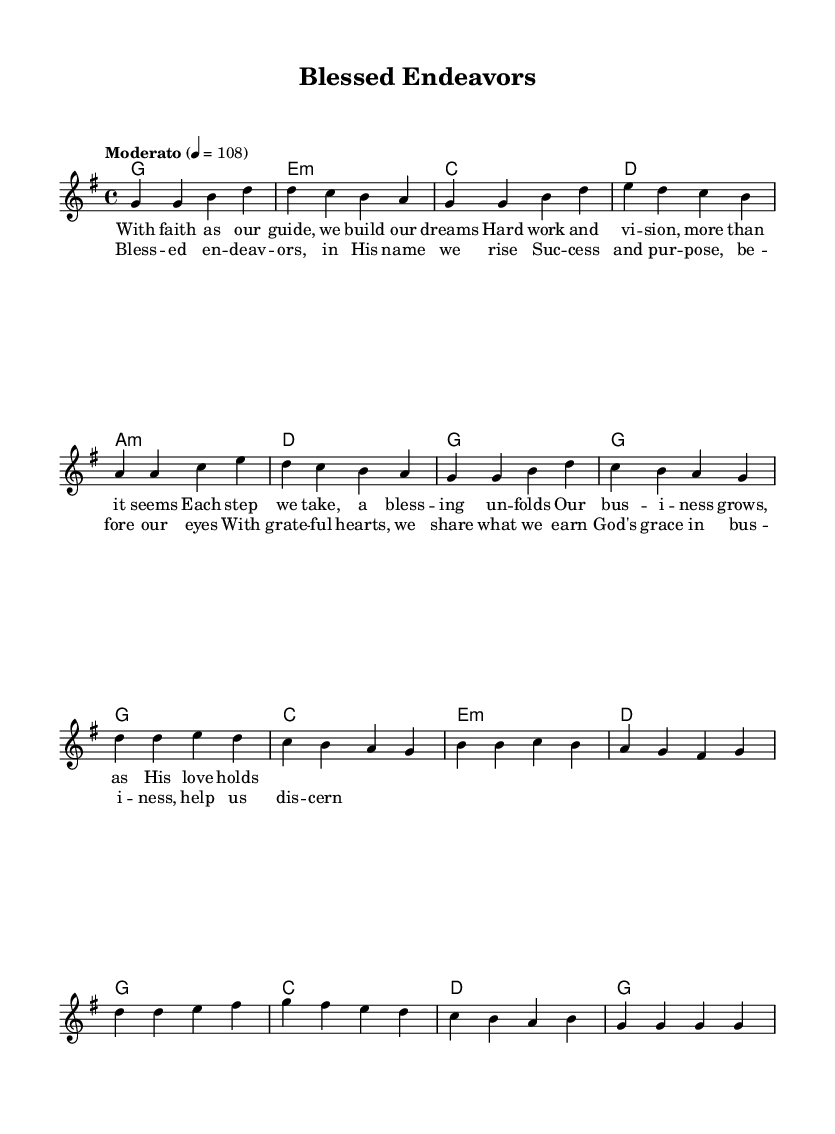What is the key signature of this music? The key signature is G major, which has one sharp (F#). This can be identified at the beginning of the sheet music where the key signature is displayed next to the clef.
Answer: G major What is the time signature of the piece? The time signature displayed is 4/4, meaning there are four beats in each measure and a quarter note receives one beat. This can be observed right after the clef and key signature at the start of the sheet music.
Answer: 4/4 What is the tempo marking of this piece? The tempo marking is "Moderato" indicating a moderate pace. The specific metronome marking, 4 = 108, indicates the speed at which the piece should be played. This is usually found just below the key signature.
Answer: Moderato How many measures are there in the verse? There are eight measures (or bars) in the verse section, which can be counted by the distinct sets of notes from the beginning of the verse to its end, indicated by the vertical lines on the staff.
Answer: Eight Which chords are used in the chorus? The chords used in the chorus are G, C, E minor, and D. These can be seen notated on the staff for the corresponding measures under the vocal melody during the chorus section.
Answer: G, C, E minor, D What theme does the chorus express? The chorus expresses the theme of divine support and gratitude in entrepreneurship. This can be understood from the lyrics which highlight being blessed in endeavors and seeing success as a result of faith.
Answer: Divine support What is the overall message conveyed in the lyrics? The overall message conveyed in the lyrics emphasizes faith, hard work, and success, linking entrepreneurship with divine guidance and blessings. This is inferred from the lyrical content and the call for discernment in business.
Answer: Faith and success 